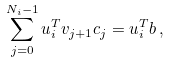<formula> <loc_0><loc_0><loc_500><loc_500>\sum _ { j = 0 } ^ { N _ { i } - 1 } u _ { i } ^ { T } v _ { j + 1 } c _ { j } = u _ { i } ^ { T } b \, ,</formula> 